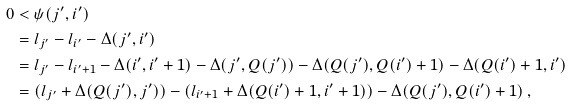<formula> <loc_0><loc_0><loc_500><loc_500>0 & < \psi ( j ^ { \prime } , i ^ { \prime } ) \\ & = l _ { j ^ { \prime } } - l _ { i ^ { \prime } } - \Delta ( j ^ { \prime } , i ^ { \prime } ) \\ & = l _ { j ^ { \prime } } - l _ { i ^ { \prime } + 1 } - \Delta ( i ^ { \prime } , i ^ { \prime } + 1 ) - \Delta ( j ^ { \prime } , Q ( j ^ { \prime } ) ) - \Delta ( Q ( j ^ { \prime } ) , Q ( i ^ { \prime } ) + 1 ) - \Delta ( Q ( i ^ { \prime } ) + 1 , i ^ { \prime } ) \\ & = ( l _ { j ^ { \prime } } + \Delta ( Q ( j ^ { \prime } ) , j ^ { \prime } ) ) - ( l _ { i ^ { \prime } + 1 } + \Delta ( Q ( i ^ { \prime } ) + 1 , i ^ { \prime } + 1 ) ) - \Delta ( Q ( j ^ { \prime } ) , Q ( i ^ { \prime } ) + 1 ) \, ,</formula> 